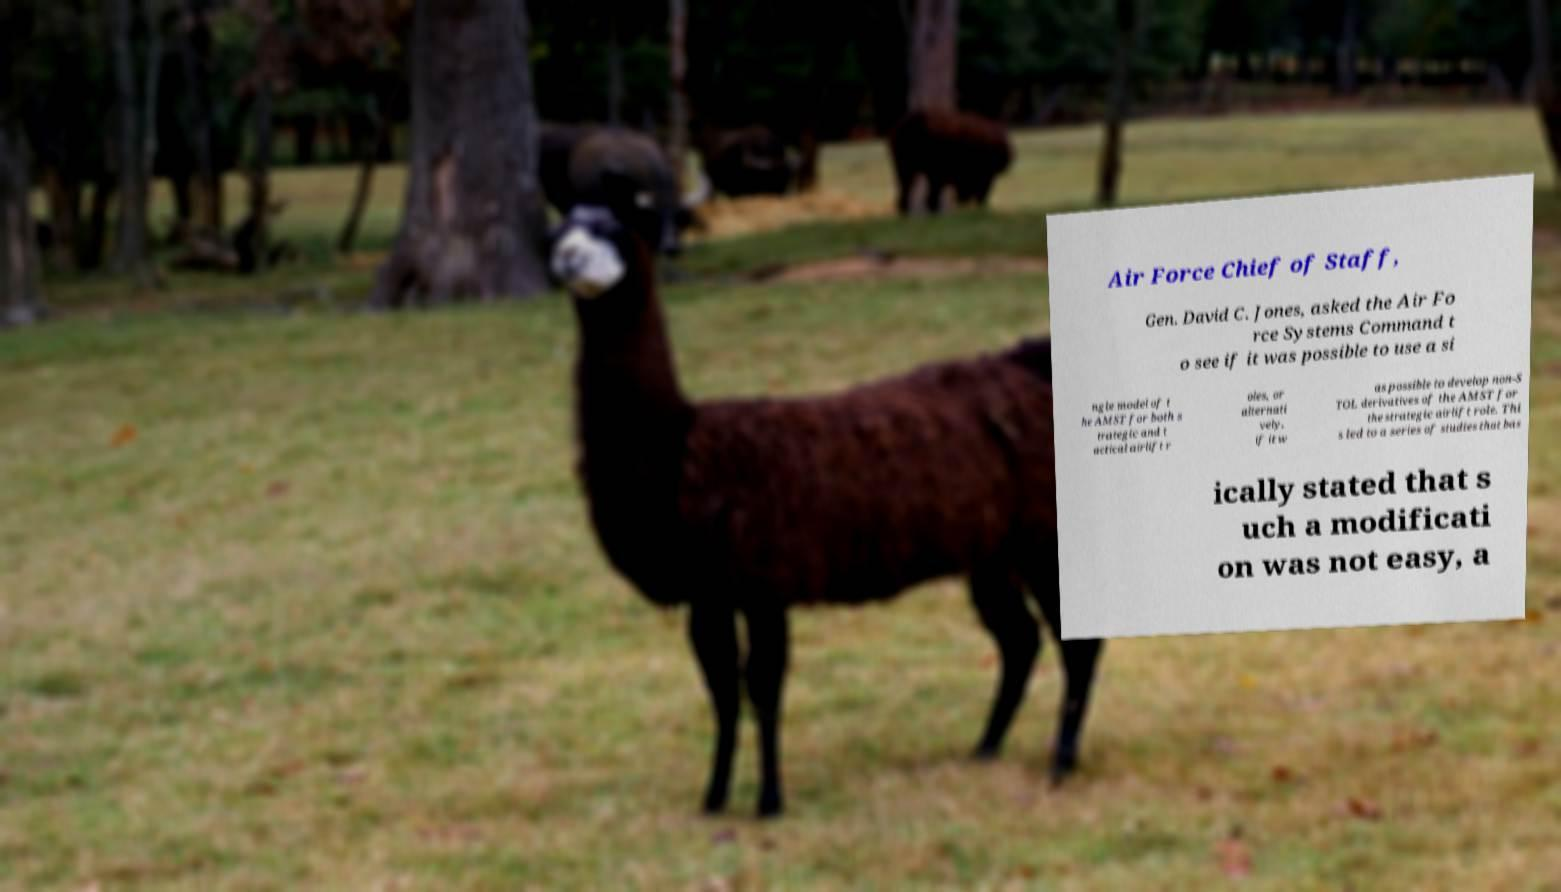Could you extract and type out the text from this image? Air Force Chief of Staff, Gen. David C. Jones, asked the Air Fo rce Systems Command t o see if it was possible to use a si ngle model of t he AMST for both s trategic and t actical airlift r oles, or alternati vely, if it w as possible to develop non-S TOL derivatives of the AMST for the strategic airlift role. Thi s led to a series of studies that bas ically stated that s uch a modificati on was not easy, a 